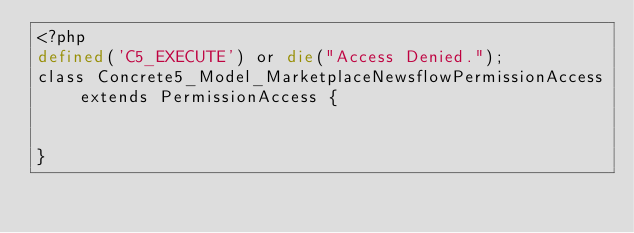Convert code to text. <code><loc_0><loc_0><loc_500><loc_500><_PHP_><?php
defined('C5_EXECUTE') or die("Access Denied.");
class Concrete5_Model_MarketplaceNewsflowPermissionAccess extends PermissionAccess {


}</code> 